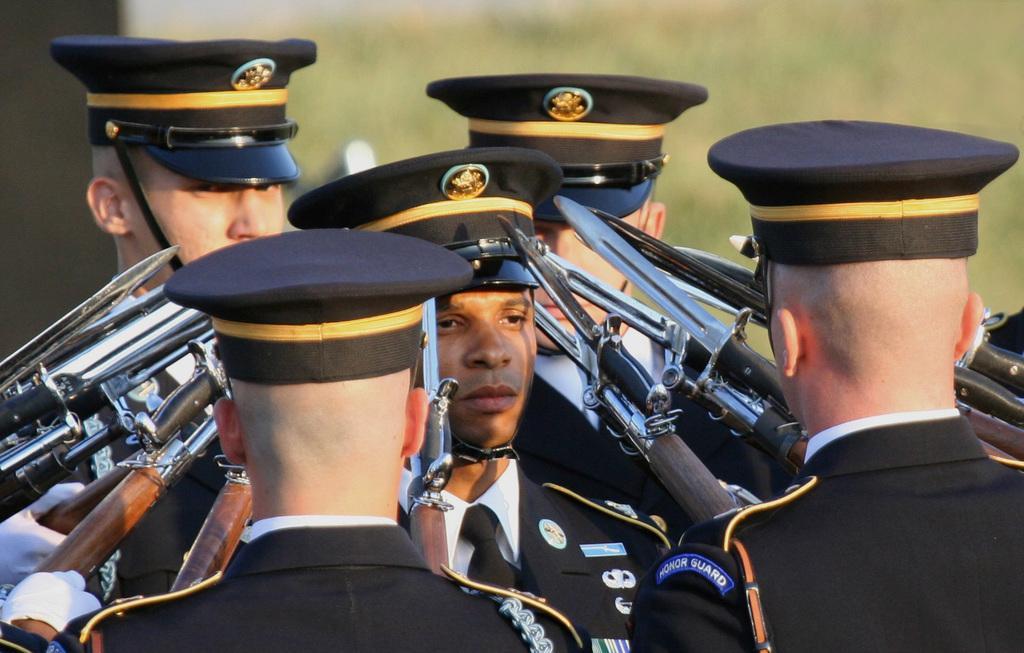Can you describe this image briefly? In this image, we can see a group of people are wearing uniforms and caps. Here we can see few weapons. Background we can see the blur view. 